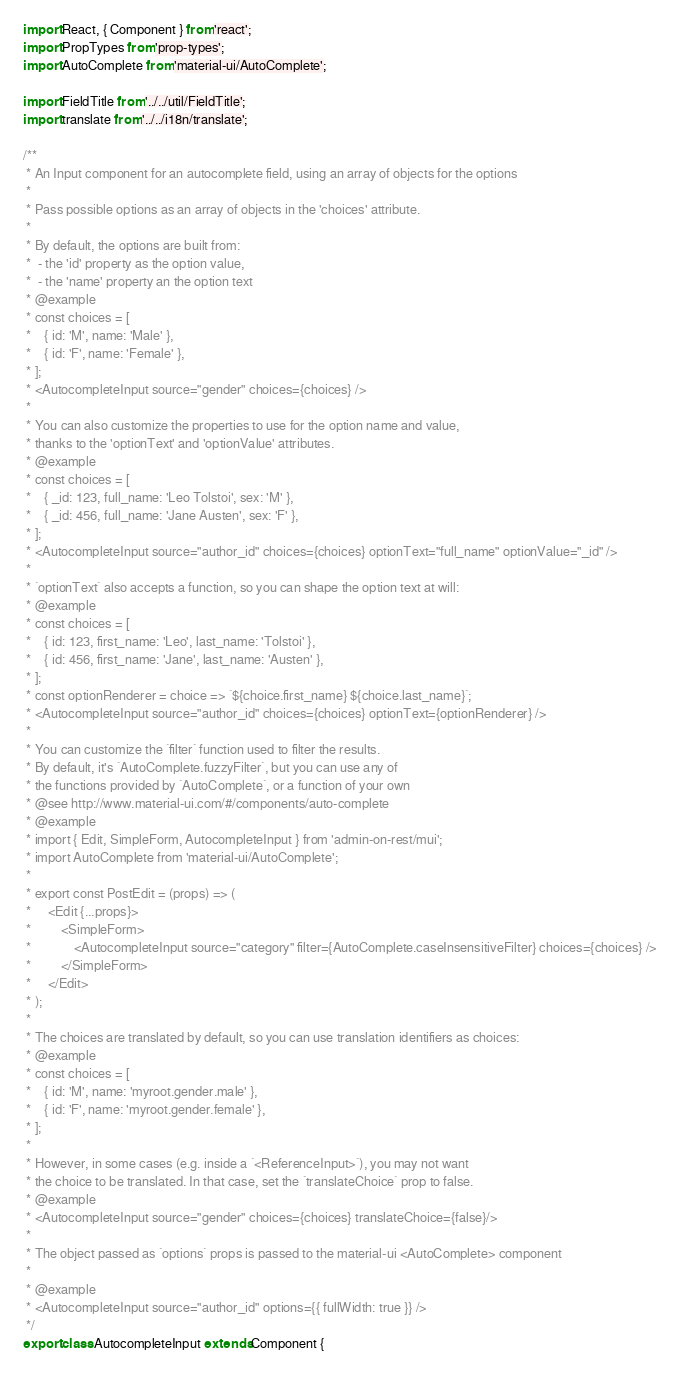<code> <loc_0><loc_0><loc_500><loc_500><_JavaScript_>import React, { Component } from 'react';
import PropTypes from 'prop-types';
import AutoComplete from 'material-ui/AutoComplete';

import FieldTitle from '../../util/FieldTitle';
import translate from '../../i18n/translate';

/**
 * An Input component for an autocomplete field, using an array of objects for the options
 *
 * Pass possible options as an array of objects in the 'choices' attribute.
 *
 * By default, the options are built from:
 *  - the 'id' property as the option value,
 *  - the 'name' property an the option text
 * @example
 * const choices = [
 *    { id: 'M', name: 'Male' },
 *    { id: 'F', name: 'Female' },
 * ];
 * <AutocompleteInput source="gender" choices={choices} />
 *
 * You can also customize the properties to use for the option name and value,
 * thanks to the 'optionText' and 'optionValue' attributes.
 * @example
 * const choices = [
 *    { _id: 123, full_name: 'Leo Tolstoi', sex: 'M' },
 *    { _id: 456, full_name: 'Jane Austen', sex: 'F' },
 * ];
 * <AutocompleteInput source="author_id" choices={choices} optionText="full_name" optionValue="_id" />
 *
 * `optionText` also accepts a function, so you can shape the option text at will:
 * @example
 * const choices = [
 *    { id: 123, first_name: 'Leo', last_name: 'Tolstoi' },
 *    { id: 456, first_name: 'Jane', last_name: 'Austen' },
 * ];
 * const optionRenderer = choice => `${choice.first_name} ${choice.last_name}`;
 * <AutocompleteInput source="author_id" choices={choices} optionText={optionRenderer} />
 *
 * You can customize the `filter` function used to filter the results.
 * By default, it's `AutoComplete.fuzzyFilter`, but you can use any of
 * the functions provided by `AutoComplete`, or a function of your own
 * @see http://www.material-ui.com/#/components/auto-complete
 * @example
 * import { Edit, SimpleForm, AutocompleteInput } from 'admin-on-rest/mui';
 * import AutoComplete from 'material-ui/AutoComplete';
 *
 * export const PostEdit = (props) => (
 *     <Edit {...props}>
 *         <SimpleForm>
 *             <AutocompleteInput source="category" filter={AutoComplete.caseInsensitiveFilter} choices={choices} />
 *         </SimpleForm>
 *     </Edit>
 * );
 *
 * The choices are translated by default, so you can use translation identifiers as choices:
 * @example
 * const choices = [
 *    { id: 'M', name: 'myroot.gender.male' },
 *    { id: 'F', name: 'myroot.gender.female' },
 * ];
 *
 * However, in some cases (e.g. inside a `<ReferenceInput>`), you may not want
 * the choice to be translated. In that case, set the `translateChoice` prop to false.
 * @example
 * <AutocompleteInput source="gender" choices={choices} translateChoice={false}/>
 *
 * The object passed as `options` props is passed to the material-ui <AutoComplete> component
 *
 * @example
 * <AutocompleteInput source="author_id" options={{ fullWidth: true }} />
 */
export class AutocompleteInput extends Component {</code> 